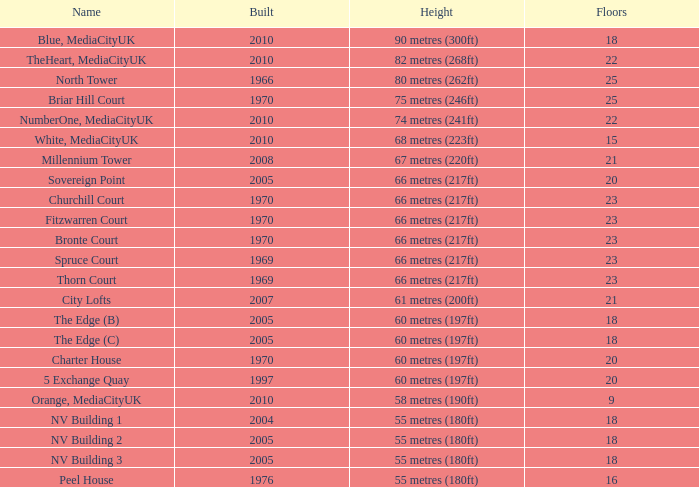What is the height of the edge (c) when its rank is under 20, it has over 9 floors, and was constructed in 2005? 60 metres (197ft). 